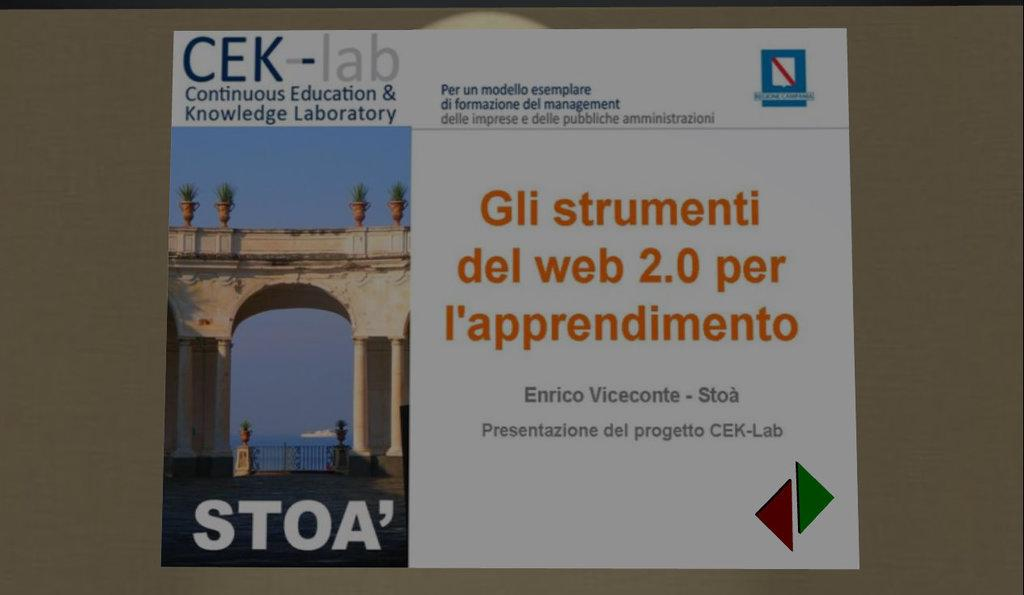<image>
Provide a brief description of the given image. a paper that says 'cek-lab continious education & knowledge laboratory' 